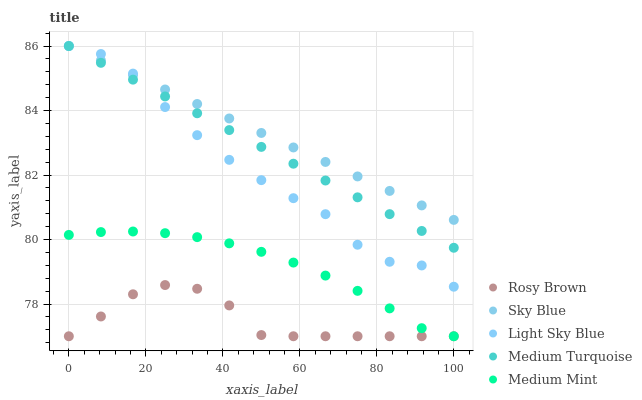Does Rosy Brown have the minimum area under the curve?
Answer yes or no. Yes. Does Sky Blue have the maximum area under the curve?
Answer yes or no. Yes. Does Sky Blue have the minimum area under the curve?
Answer yes or no. No. Does Rosy Brown have the maximum area under the curve?
Answer yes or no. No. Is Sky Blue the smoothest?
Answer yes or no. Yes. Is Light Sky Blue the roughest?
Answer yes or no. Yes. Is Rosy Brown the smoothest?
Answer yes or no. No. Is Rosy Brown the roughest?
Answer yes or no. No. Does Medium Mint have the lowest value?
Answer yes or no. Yes. Does Sky Blue have the lowest value?
Answer yes or no. No. Does Light Sky Blue have the highest value?
Answer yes or no. Yes. Does Rosy Brown have the highest value?
Answer yes or no. No. Is Medium Mint less than Light Sky Blue?
Answer yes or no. Yes. Is Light Sky Blue greater than Rosy Brown?
Answer yes or no. Yes. Does Medium Mint intersect Rosy Brown?
Answer yes or no. Yes. Is Medium Mint less than Rosy Brown?
Answer yes or no. No. Is Medium Mint greater than Rosy Brown?
Answer yes or no. No. Does Medium Mint intersect Light Sky Blue?
Answer yes or no. No. 